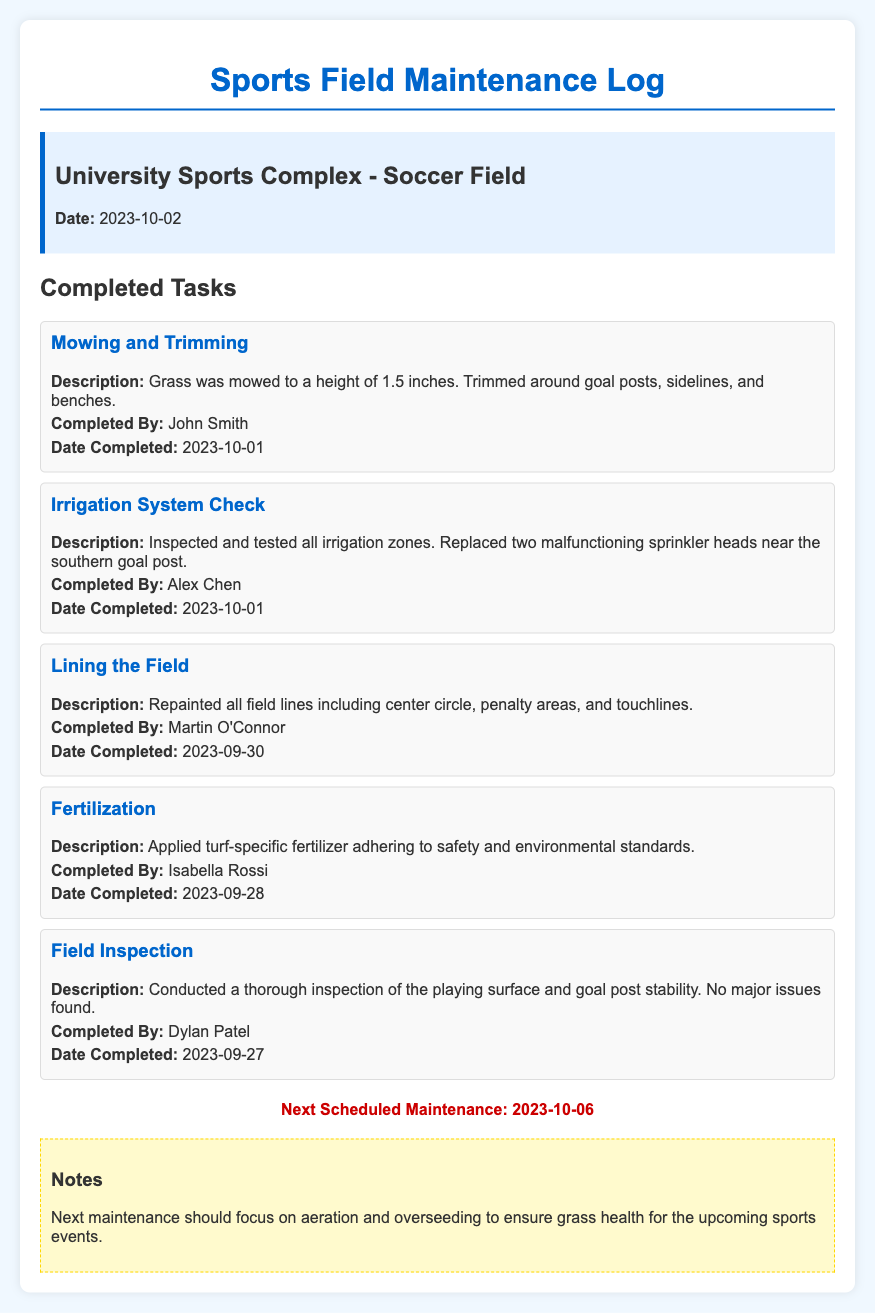what is the date of the latest completed maintenance task? The date of the latest completed maintenance task is mentioned under "Date Completed" for the task "Mowing and Trimming," which is 2023-10-01.
Answer: 2023-10-01 who completed the irrigation system check? The "Completed By" section for the "Irrigation System Check" task identifies the person who completed it as Alex Chen.
Answer: Alex Chen how many tasks were completed before the next scheduled maintenance? The document lists all tasks completed prior to the next scheduled maintenance, which is five.
Answer: 5 what is the next scheduled maintenance date? The "Next Scheduled Maintenance" section provides a specific date of the upcoming maintenance task, which is 2023-10-06.
Answer: 2023-10-06 what task involved repainting field lines? The task with the description of repainting field lines is titled "Lining the Field."
Answer: Lining the Field what is the purpose of the next maintenance according to the notes? The "Notes" section outlines the focus of the upcoming maintenance, which is on aeration and overseeding for grass health.
Answer: aeration and overseeding who was responsible for fertilization? The "Completed By" section for the "Fertilization" task attributes the responsibility to Isabella Rossi.
Answer: Isabella Rossi which task was completed on 2023-09-30? The document records the completion date of the task "Lining the Field" as 2023-09-30.
Answer: Lining the Field 